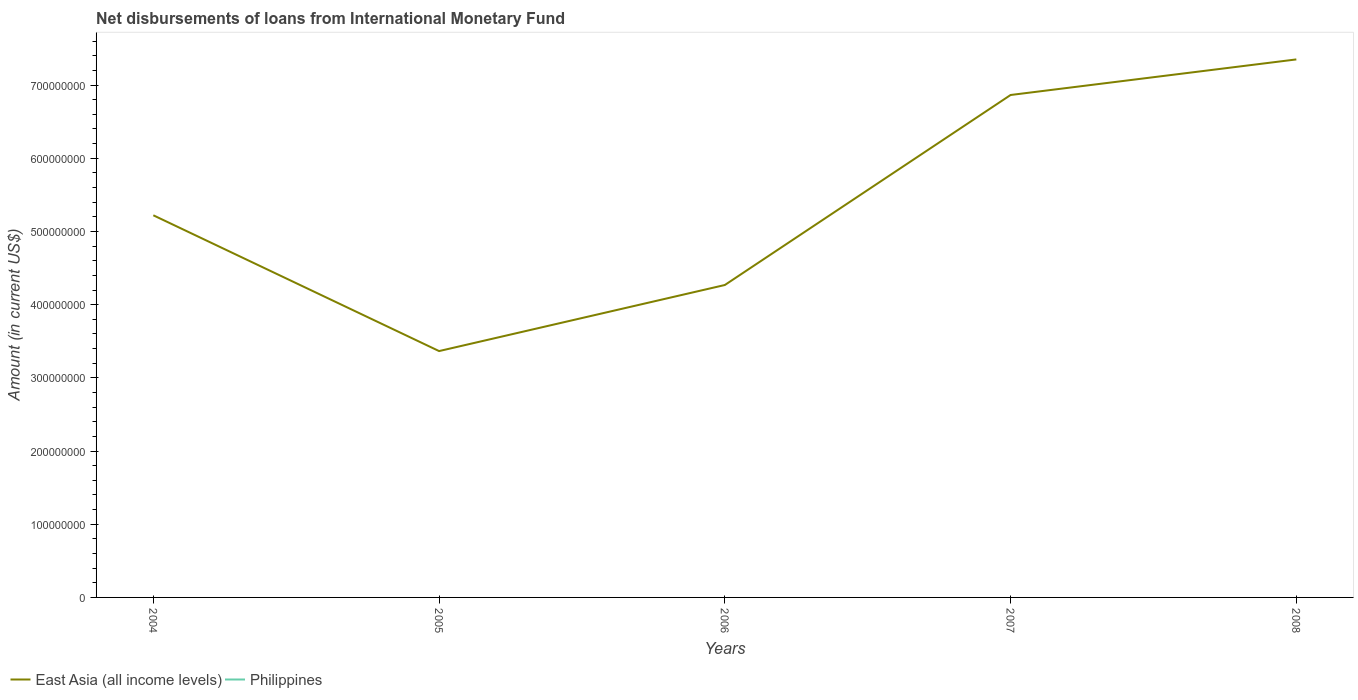Is the number of lines equal to the number of legend labels?
Give a very brief answer. No. Across all years, what is the maximum amount of loans disbursed in East Asia (all income levels)?
Make the answer very short. 3.37e+08. What is the total amount of loans disbursed in East Asia (all income levels) in the graph?
Keep it short and to the point. 1.86e+08. What is the difference between the highest and the second highest amount of loans disbursed in East Asia (all income levels)?
Keep it short and to the point. 3.98e+08. What is the difference between the highest and the lowest amount of loans disbursed in Philippines?
Provide a short and direct response. 0. Is the amount of loans disbursed in Philippines strictly greater than the amount of loans disbursed in East Asia (all income levels) over the years?
Keep it short and to the point. Yes. What is the difference between two consecutive major ticks on the Y-axis?
Provide a short and direct response. 1.00e+08. Are the values on the major ticks of Y-axis written in scientific E-notation?
Your answer should be compact. No. Does the graph contain grids?
Your answer should be compact. No. How are the legend labels stacked?
Provide a short and direct response. Horizontal. What is the title of the graph?
Your answer should be compact. Net disbursements of loans from International Monetary Fund. What is the label or title of the X-axis?
Offer a very short reply. Years. What is the label or title of the Y-axis?
Offer a very short reply. Amount (in current US$). What is the Amount (in current US$) in East Asia (all income levels) in 2004?
Your response must be concise. 5.22e+08. What is the Amount (in current US$) of Philippines in 2004?
Offer a terse response. 0. What is the Amount (in current US$) in East Asia (all income levels) in 2005?
Give a very brief answer. 3.37e+08. What is the Amount (in current US$) in Philippines in 2005?
Your response must be concise. 0. What is the Amount (in current US$) of East Asia (all income levels) in 2006?
Your response must be concise. 4.27e+08. What is the Amount (in current US$) of Philippines in 2006?
Your response must be concise. 0. What is the Amount (in current US$) in East Asia (all income levels) in 2007?
Your answer should be compact. 6.86e+08. What is the Amount (in current US$) of Philippines in 2007?
Provide a short and direct response. 0. What is the Amount (in current US$) of East Asia (all income levels) in 2008?
Offer a very short reply. 7.35e+08. What is the Amount (in current US$) of Philippines in 2008?
Keep it short and to the point. 0. Across all years, what is the maximum Amount (in current US$) in East Asia (all income levels)?
Make the answer very short. 7.35e+08. Across all years, what is the minimum Amount (in current US$) in East Asia (all income levels)?
Provide a succinct answer. 3.37e+08. What is the total Amount (in current US$) in East Asia (all income levels) in the graph?
Ensure brevity in your answer.  2.71e+09. What is the total Amount (in current US$) in Philippines in the graph?
Your answer should be very brief. 0. What is the difference between the Amount (in current US$) of East Asia (all income levels) in 2004 and that in 2005?
Ensure brevity in your answer.  1.86e+08. What is the difference between the Amount (in current US$) of East Asia (all income levels) in 2004 and that in 2006?
Provide a succinct answer. 9.53e+07. What is the difference between the Amount (in current US$) of East Asia (all income levels) in 2004 and that in 2007?
Give a very brief answer. -1.64e+08. What is the difference between the Amount (in current US$) of East Asia (all income levels) in 2004 and that in 2008?
Your answer should be very brief. -2.13e+08. What is the difference between the Amount (in current US$) of East Asia (all income levels) in 2005 and that in 2006?
Make the answer very short. -9.03e+07. What is the difference between the Amount (in current US$) of East Asia (all income levels) in 2005 and that in 2007?
Offer a very short reply. -3.50e+08. What is the difference between the Amount (in current US$) of East Asia (all income levels) in 2005 and that in 2008?
Your response must be concise. -3.98e+08. What is the difference between the Amount (in current US$) of East Asia (all income levels) in 2006 and that in 2007?
Make the answer very short. -2.60e+08. What is the difference between the Amount (in current US$) in East Asia (all income levels) in 2006 and that in 2008?
Give a very brief answer. -3.08e+08. What is the difference between the Amount (in current US$) of East Asia (all income levels) in 2007 and that in 2008?
Offer a terse response. -4.86e+07. What is the average Amount (in current US$) of East Asia (all income levels) per year?
Ensure brevity in your answer.  5.41e+08. What is the average Amount (in current US$) of Philippines per year?
Your response must be concise. 0. What is the ratio of the Amount (in current US$) of East Asia (all income levels) in 2004 to that in 2005?
Make the answer very short. 1.55. What is the ratio of the Amount (in current US$) of East Asia (all income levels) in 2004 to that in 2006?
Keep it short and to the point. 1.22. What is the ratio of the Amount (in current US$) in East Asia (all income levels) in 2004 to that in 2007?
Your response must be concise. 0.76. What is the ratio of the Amount (in current US$) of East Asia (all income levels) in 2004 to that in 2008?
Your answer should be very brief. 0.71. What is the ratio of the Amount (in current US$) in East Asia (all income levels) in 2005 to that in 2006?
Give a very brief answer. 0.79. What is the ratio of the Amount (in current US$) of East Asia (all income levels) in 2005 to that in 2007?
Provide a short and direct response. 0.49. What is the ratio of the Amount (in current US$) of East Asia (all income levels) in 2005 to that in 2008?
Provide a succinct answer. 0.46. What is the ratio of the Amount (in current US$) in East Asia (all income levels) in 2006 to that in 2007?
Offer a terse response. 0.62. What is the ratio of the Amount (in current US$) of East Asia (all income levels) in 2006 to that in 2008?
Make the answer very short. 0.58. What is the ratio of the Amount (in current US$) in East Asia (all income levels) in 2007 to that in 2008?
Offer a very short reply. 0.93. What is the difference between the highest and the second highest Amount (in current US$) in East Asia (all income levels)?
Offer a very short reply. 4.86e+07. What is the difference between the highest and the lowest Amount (in current US$) in East Asia (all income levels)?
Your answer should be compact. 3.98e+08. 